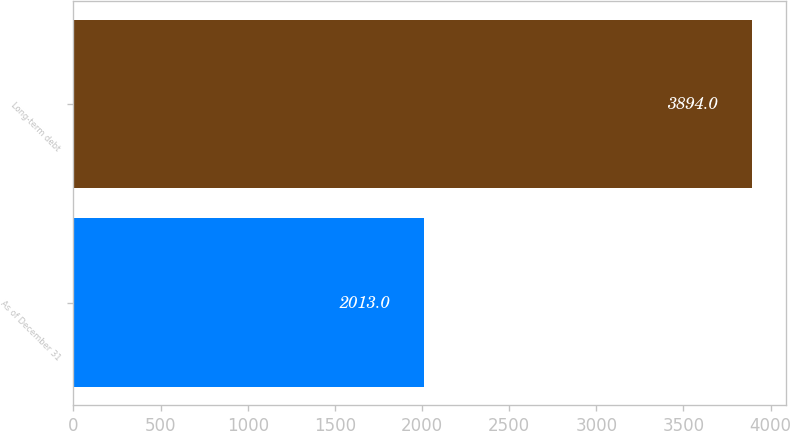Convert chart. <chart><loc_0><loc_0><loc_500><loc_500><bar_chart><fcel>As of December 31<fcel>Long-term debt<nl><fcel>2013<fcel>3894<nl></chart> 